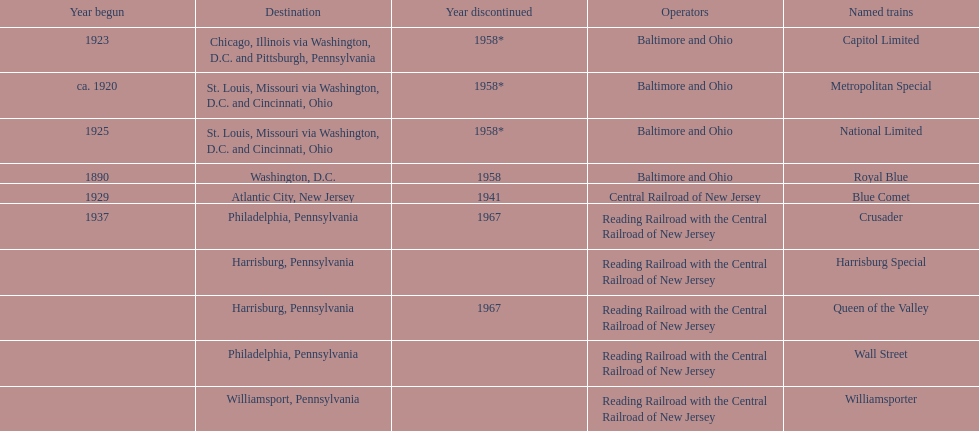What was the first train to begin service? Royal Blue. 